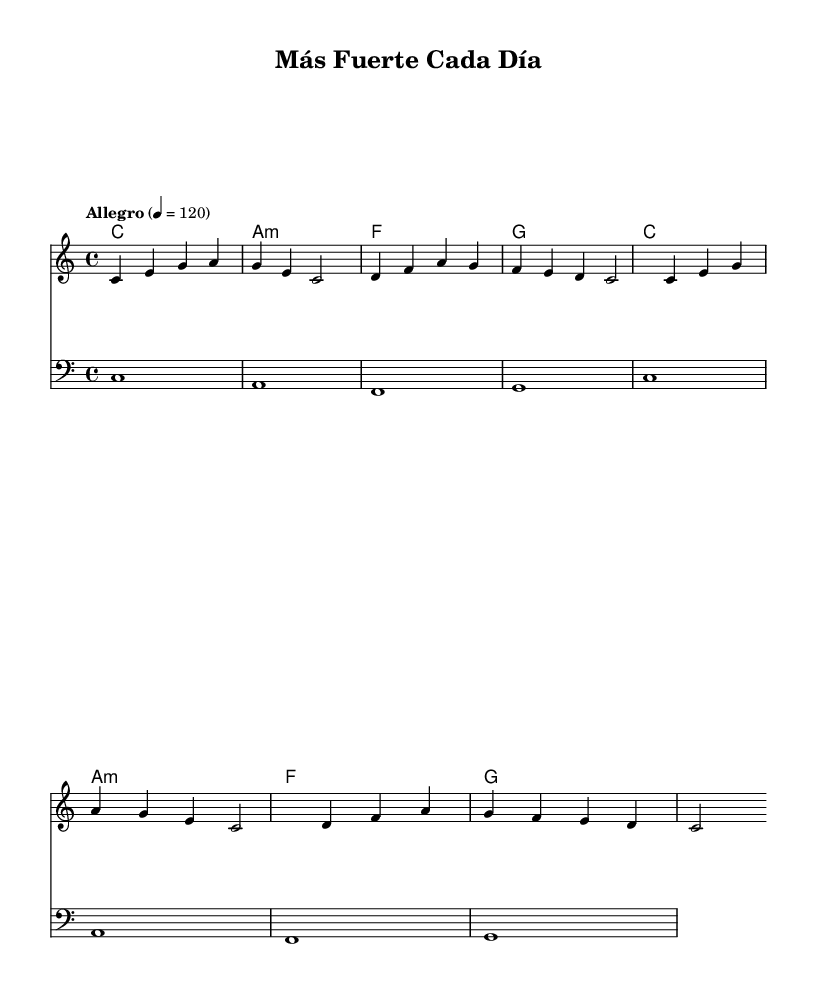What is the key signature of this music? The key signature is indicated as "c" in the global context, which denotes C major, and there are no sharps or flats present.
Answer: C major What is the time signature of the piece? The time signature is indicated in the global context as "4/4", which means there are four beats in each measure and the quarter note gets one beat.
Answer: 4/4 What is the tempo marking for this piece? The tempo marking is noted as "Allegro" in the global context, indicating a fast, lively tempo, specifically set to 120 beats per minute.
Answer: Allegro How many measures are in the provided melody? The melody section contains a total of 8 measures, as evidenced by counting the groupings of notes and bars in the score.
Answer: 8 What is the first chord in the harmony section? The first chord listed in the harmonies indicates "c1", which denotes a C major chord played for the first full measure.
Answer: C How many lines of lyrics are sung in the verse? The verse consists of 4 lines of lyrics indicated in the lyric mode section of the score, as divided by the hyphens and phrases.
Answer: 4 What is the mood suggested by the lyrics and melody of the piece? The lyrics express themes of resilience and determination, combined with an uplifting melody, suggesting a positive and hopeful mood overall.
Answer: Uplifting 